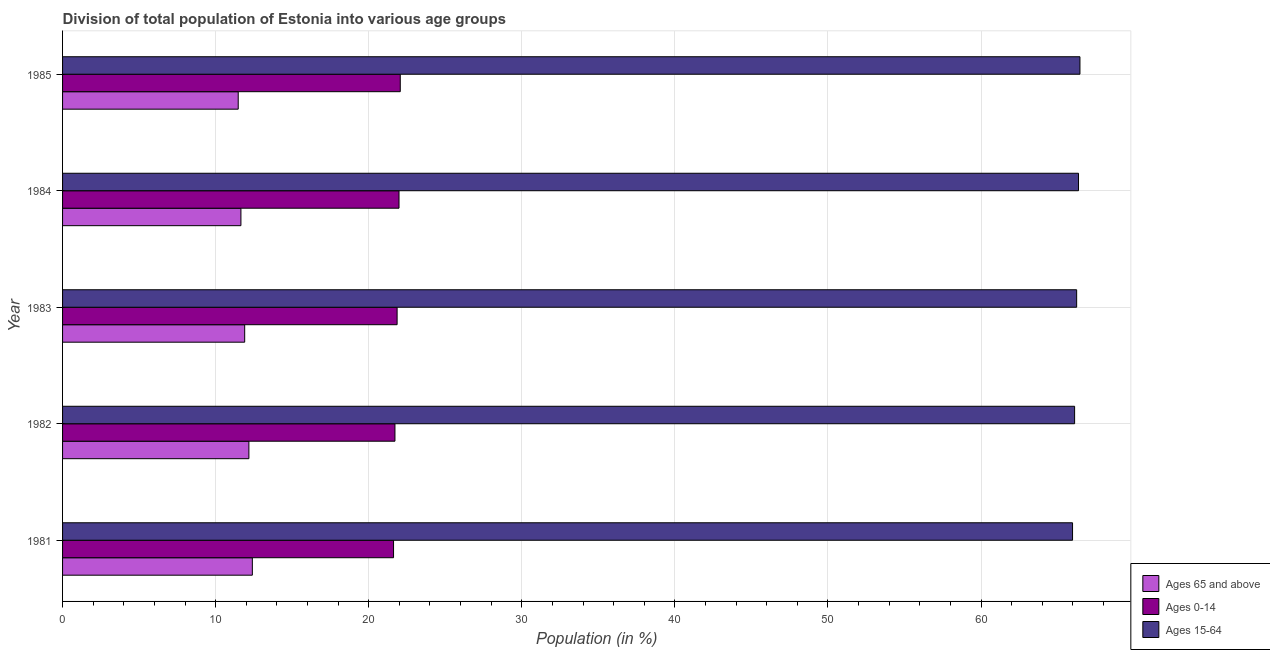How many different coloured bars are there?
Ensure brevity in your answer.  3. How many bars are there on the 4th tick from the top?
Offer a terse response. 3. How many bars are there on the 2nd tick from the bottom?
Your answer should be compact. 3. What is the label of the 3rd group of bars from the top?
Ensure brevity in your answer.  1983. In how many cases, is the number of bars for a given year not equal to the number of legend labels?
Give a very brief answer. 0. What is the percentage of population within the age-group of 65 and above in 1985?
Make the answer very short. 11.48. Across all years, what is the maximum percentage of population within the age-group 0-14?
Provide a short and direct response. 22.06. Across all years, what is the minimum percentage of population within the age-group 15-64?
Give a very brief answer. 65.98. In which year was the percentage of population within the age-group 0-14 maximum?
Keep it short and to the point. 1985. In which year was the percentage of population within the age-group 15-64 minimum?
Make the answer very short. 1981. What is the total percentage of population within the age-group of 65 and above in the graph?
Provide a short and direct response. 59.59. What is the difference between the percentage of population within the age-group 15-64 in 1985 and the percentage of population within the age-group 0-14 in 1981?
Make the answer very short. 44.84. What is the average percentage of population within the age-group 0-14 per year?
Your response must be concise. 21.85. In the year 1982, what is the difference between the percentage of population within the age-group 15-64 and percentage of population within the age-group of 65 and above?
Offer a very short reply. 53.94. What is the ratio of the percentage of population within the age-group 0-14 in 1983 to that in 1985?
Offer a very short reply. 0.99. Is the percentage of population within the age-group 0-14 in 1981 less than that in 1984?
Give a very brief answer. Yes. What is the difference between the highest and the second highest percentage of population within the age-group of 65 and above?
Your answer should be very brief. 0.23. What is the difference between the highest and the lowest percentage of population within the age-group 0-14?
Offer a terse response. 0.44. In how many years, is the percentage of population within the age-group of 65 and above greater than the average percentage of population within the age-group of 65 and above taken over all years?
Ensure brevity in your answer.  2. What does the 1st bar from the top in 1984 represents?
Offer a very short reply. Ages 15-64. What does the 2nd bar from the bottom in 1985 represents?
Offer a very short reply. Ages 0-14. What is the difference between two consecutive major ticks on the X-axis?
Offer a very short reply. 10. Are the values on the major ticks of X-axis written in scientific E-notation?
Keep it short and to the point. No. Where does the legend appear in the graph?
Keep it short and to the point. Bottom right. How many legend labels are there?
Your answer should be very brief. 3. What is the title of the graph?
Ensure brevity in your answer.  Division of total population of Estonia into various age groups
. Does "Industrial Nitrous Oxide" appear as one of the legend labels in the graph?
Your answer should be very brief. No. What is the Population (in %) in Ages 65 and above in 1981?
Your answer should be very brief. 12.4. What is the Population (in %) of Ages 0-14 in 1981?
Offer a terse response. 21.62. What is the Population (in %) in Ages 15-64 in 1981?
Your answer should be very brief. 65.98. What is the Population (in %) of Ages 65 and above in 1982?
Offer a very short reply. 12.17. What is the Population (in %) of Ages 0-14 in 1982?
Your answer should be compact. 21.71. What is the Population (in %) in Ages 15-64 in 1982?
Your response must be concise. 66.11. What is the Population (in %) of Ages 65 and above in 1983?
Offer a very short reply. 11.9. What is the Population (in %) in Ages 0-14 in 1983?
Make the answer very short. 21.85. What is the Population (in %) in Ages 15-64 in 1983?
Keep it short and to the point. 66.25. What is the Population (in %) in Ages 65 and above in 1984?
Your response must be concise. 11.65. What is the Population (in %) of Ages 0-14 in 1984?
Keep it short and to the point. 21.98. What is the Population (in %) of Ages 15-64 in 1984?
Give a very brief answer. 66.37. What is the Population (in %) of Ages 65 and above in 1985?
Make the answer very short. 11.48. What is the Population (in %) in Ages 0-14 in 1985?
Your answer should be very brief. 22.06. What is the Population (in %) in Ages 15-64 in 1985?
Ensure brevity in your answer.  66.46. Across all years, what is the maximum Population (in %) in Ages 65 and above?
Your answer should be very brief. 12.4. Across all years, what is the maximum Population (in %) in Ages 0-14?
Offer a very short reply. 22.06. Across all years, what is the maximum Population (in %) in Ages 15-64?
Provide a short and direct response. 66.46. Across all years, what is the minimum Population (in %) in Ages 65 and above?
Make the answer very short. 11.48. Across all years, what is the minimum Population (in %) in Ages 0-14?
Give a very brief answer. 21.62. Across all years, what is the minimum Population (in %) of Ages 15-64?
Keep it short and to the point. 65.98. What is the total Population (in %) of Ages 65 and above in the graph?
Your answer should be very brief. 59.59. What is the total Population (in %) in Ages 0-14 in the graph?
Your response must be concise. 109.23. What is the total Population (in %) of Ages 15-64 in the graph?
Make the answer very short. 331.17. What is the difference between the Population (in %) of Ages 65 and above in 1981 and that in 1982?
Provide a succinct answer. 0.23. What is the difference between the Population (in %) of Ages 0-14 in 1981 and that in 1982?
Your response must be concise. -0.09. What is the difference between the Population (in %) in Ages 15-64 in 1981 and that in 1982?
Offer a very short reply. -0.13. What is the difference between the Population (in %) in Ages 65 and above in 1981 and that in 1983?
Provide a short and direct response. 0.5. What is the difference between the Population (in %) in Ages 0-14 in 1981 and that in 1983?
Your answer should be very brief. -0.23. What is the difference between the Population (in %) of Ages 15-64 in 1981 and that in 1983?
Keep it short and to the point. -0.27. What is the difference between the Population (in %) in Ages 65 and above in 1981 and that in 1984?
Make the answer very short. 0.75. What is the difference between the Population (in %) of Ages 0-14 in 1981 and that in 1984?
Ensure brevity in your answer.  -0.36. What is the difference between the Population (in %) of Ages 15-64 in 1981 and that in 1984?
Offer a very short reply. -0.39. What is the difference between the Population (in %) of Ages 65 and above in 1981 and that in 1985?
Offer a terse response. 0.92. What is the difference between the Population (in %) of Ages 0-14 in 1981 and that in 1985?
Offer a very short reply. -0.44. What is the difference between the Population (in %) in Ages 15-64 in 1981 and that in 1985?
Provide a succinct answer. -0.48. What is the difference between the Population (in %) in Ages 65 and above in 1982 and that in 1983?
Make the answer very short. 0.27. What is the difference between the Population (in %) in Ages 0-14 in 1982 and that in 1983?
Provide a short and direct response. -0.14. What is the difference between the Population (in %) of Ages 15-64 in 1982 and that in 1983?
Keep it short and to the point. -0.13. What is the difference between the Population (in %) of Ages 65 and above in 1982 and that in 1984?
Provide a short and direct response. 0.52. What is the difference between the Population (in %) in Ages 0-14 in 1982 and that in 1984?
Make the answer very short. -0.27. What is the difference between the Population (in %) in Ages 15-64 in 1982 and that in 1984?
Your answer should be compact. -0.26. What is the difference between the Population (in %) of Ages 65 and above in 1982 and that in 1985?
Offer a very short reply. 0.7. What is the difference between the Population (in %) of Ages 0-14 in 1982 and that in 1985?
Make the answer very short. -0.35. What is the difference between the Population (in %) in Ages 15-64 in 1982 and that in 1985?
Offer a very short reply. -0.35. What is the difference between the Population (in %) of Ages 65 and above in 1983 and that in 1984?
Your response must be concise. 0.25. What is the difference between the Population (in %) in Ages 0-14 in 1983 and that in 1984?
Your answer should be compact. -0.12. What is the difference between the Population (in %) in Ages 15-64 in 1983 and that in 1984?
Offer a very short reply. -0.12. What is the difference between the Population (in %) of Ages 65 and above in 1983 and that in 1985?
Offer a very short reply. 0.42. What is the difference between the Population (in %) of Ages 0-14 in 1983 and that in 1985?
Your response must be concise. -0.21. What is the difference between the Population (in %) in Ages 15-64 in 1983 and that in 1985?
Your answer should be very brief. -0.22. What is the difference between the Population (in %) in Ages 65 and above in 1984 and that in 1985?
Offer a very short reply. 0.18. What is the difference between the Population (in %) in Ages 0-14 in 1984 and that in 1985?
Your answer should be very brief. -0.08. What is the difference between the Population (in %) of Ages 15-64 in 1984 and that in 1985?
Your answer should be compact. -0.09. What is the difference between the Population (in %) in Ages 65 and above in 1981 and the Population (in %) in Ages 0-14 in 1982?
Offer a terse response. -9.32. What is the difference between the Population (in %) in Ages 65 and above in 1981 and the Population (in %) in Ages 15-64 in 1982?
Provide a short and direct response. -53.72. What is the difference between the Population (in %) of Ages 0-14 in 1981 and the Population (in %) of Ages 15-64 in 1982?
Provide a short and direct response. -44.49. What is the difference between the Population (in %) in Ages 65 and above in 1981 and the Population (in %) in Ages 0-14 in 1983?
Provide a short and direct response. -9.46. What is the difference between the Population (in %) in Ages 65 and above in 1981 and the Population (in %) in Ages 15-64 in 1983?
Keep it short and to the point. -53.85. What is the difference between the Population (in %) in Ages 0-14 in 1981 and the Population (in %) in Ages 15-64 in 1983?
Offer a terse response. -44.63. What is the difference between the Population (in %) of Ages 65 and above in 1981 and the Population (in %) of Ages 0-14 in 1984?
Provide a succinct answer. -9.58. What is the difference between the Population (in %) in Ages 65 and above in 1981 and the Population (in %) in Ages 15-64 in 1984?
Your answer should be very brief. -53.97. What is the difference between the Population (in %) in Ages 0-14 in 1981 and the Population (in %) in Ages 15-64 in 1984?
Your response must be concise. -44.75. What is the difference between the Population (in %) in Ages 65 and above in 1981 and the Population (in %) in Ages 0-14 in 1985?
Your answer should be compact. -9.66. What is the difference between the Population (in %) of Ages 65 and above in 1981 and the Population (in %) of Ages 15-64 in 1985?
Keep it short and to the point. -54.07. What is the difference between the Population (in %) in Ages 0-14 in 1981 and the Population (in %) in Ages 15-64 in 1985?
Your answer should be very brief. -44.84. What is the difference between the Population (in %) of Ages 65 and above in 1982 and the Population (in %) of Ages 0-14 in 1983?
Offer a very short reply. -9.68. What is the difference between the Population (in %) of Ages 65 and above in 1982 and the Population (in %) of Ages 15-64 in 1983?
Provide a short and direct response. -54.08. What is the difference between the Population (in %) in Ages 0-14 in 1982 and the Population (in %) in Ages 15-64 in 1983?
Provide a short and direct response. -44.53. What is the difference between the Population (in %) of Ages 65 and above in 1982 and the Population (in %) of Ages 0-14 in 1984?
Your answer should be compact. -9.81. What is the difference between the Population (in %) of Ages 65 and above in 1982 and the Population (in %) of Ages 15-64 in 1984?
Offer a terse response. -54.2. What is the difference between the Population (in %) in Ages 0-14 in 1982 and the Population (in %) in Ages 15-64 in 1984?
Your response must be concise. -44.66. What is the difference between the Population (in %) in Ages 65 and above in 1982 and the Population (in %) in Ages 0-14 in 1985?
Your answer should be very brief. -9.89. What is the difference between the Population (in %) of Ages 65 and above in 1982 and the Population (in %) of Ages 15-64 in 1985?
Give a very brief answer. -54.29. What is the difference between the Population (in %) in Ages 0-14 in 1982 and the Population (in %) in Ages 15-64 in 1985?
Make the answer very short. -44.75. What is the difference between the Population (in %) of Ages 65 and above in 1983 and the Population (in %) of Ages 0-14 in 1984?
Your response must be concise. -10.08. What is the difference between the Population (in %) in Ages 65 and above in 1983 and the Population (in %) in Ages 15-64 in 1984?
Your answer should be very brief. -54.47. What is the difference between the Population (in %) in Ages 0-14 in 1983 and the Population (in %) in Ages 15-64 in 1984?
Offer a very short reply. -44.51. What is the difference between the Population (in %) in Ages 65 and above in 1983 and the Population (in %) in Ages 0-14 in 1985?
Offer a terse response. -10.16. What is the difference between the Population (in %) in Ages 65 and above in 1983 and the Population (in %) in Ages 15-64 in 1985?
Provide a short and direct response. -54.57. What is the difference between the Population (in %) of Ages 0-14 in 1983 and the Population (in %) of Ages 15-64 in 1985?
Your answer should be compact. -44.61. What is the difference between the Population (in %) of Ages 65 and above in 1984 and the Population (in %) of Ages 0-14 in 1985?
Offer a terse response. -10.41. What is the difference between the Population (in %) of Ages 65 and above in 1984 and the Population (in %) of Ages 15-64 in 1985?
Your answer should be very brief. -54.81. What is the difference between the Population (in %) in Ages 0-14 in 1984 and the Population (in %) in Ages 15-64 in 1985?
Your response must be concise. -44.48. What is the average Population (in %) in Ages 65 and above per year?
Your answer should be very brief. 11.92. What is the average Population (in %) of Ages 0-14 per year?
Offer a terse response. 21.85. What is the average Population (in %) in Ages 15-64 per year?
Provide a short and direct response. 66.23. In the year 1981, what is the difference between the Population (in %) in Ages 65 and above and Population (in %) in Ages 0-14?
Ensure brevity in your answer.  -9.22. In the year 1981, what is the difference between the Population (in %) in Ages 65 and above and Population (in %) in Ages 15-64?
Provide a succinct answer. -53.58. In the year 1981, what is the difference between the Population (in %) of Ages 0-14 and Population (in %) of Ages 15-64?
Provide a succinct answer. -44.36. In the year 1982, what is the difference between the Population (in %) in Ages 65 and above and Population (in %) in Ages 0-14?
Provide a short and direct response. -9.54. In the year 1982, what is the difference between the Population (in %) of Ages 65 and above and Population (in %) of Ages 15-64?
Ensure brevity in your answer.  -53.94. In the year 1982, what is the difference between the Population (in %) in Ages 0-14 and Population (in %) in Ages 15-64?
Provide a short and direct response. -44.4. In the year 1983, what is the difference between the Population (in %) in Ages 65 and above and Population (in %) in Ages 0-14?
Ensure brevity in your answer.  -9.96. In the year 1983, what is the difference between the Population (in %) of Ages 65 and above and Population (in %) of Ages 15-64?
Keep it short and to the point. -54.35. In the year 1983, what is the difference between the Population (in %) of Ages 0-14 and Population (in %) of Ages 15-64?
Offer a terse response. -44.39. In the year 1984, what is the difference between the Population (in %) in Ages 65 and above and Population (in %) in Ages 0-14?
Offer a very short reply. -10.33. In the year 1984, what is the difference between the Population (in %) of Ages 65 and above and Population (in %) of Ages 15-64?
Your answer should be compact. -54.72. In the year 1984, what is the difference between the Population (in %) in Ages 0-14 and Population (in %) in Ages 15-64?
Offer a very short reply. -44.39. In the year 1985, what is the difference between the Population (in %) of Ages 65 and above and Population (in %) of Ages 0-14?
Keep it short and to the point. -10.59. In the year 1985, what is the difference between the Population (in %) of Ages 65 and above and Population (in %) of Ages 15-64?
Offer a terse response. -54.99. In the year 1985, what is the difference between the Population (in %) in Ages 0-14 and Population (in %) in Ages 15-64?
Give a very brief answer. -44.4. What is the ratio of the Population (in %) of Ages 65 and above in 1981 to that in 1982?
Provide a succinct answer. 1.02. What is the ratio of the Population (in %) in Ages 0-14 in 1981 to that in 1982?
Offer a terse response. 1. What is the ratio of the Population (in %) in Ages 15-64 in 1981 to that in 1982?
Ensure brevity in your answer.  1. What is the ratio of the Population (in %) of Ages 65 and above in 1981 to that in 1983?
Provide a short and direct response. 1.04. What is the ratio of the Population (in %) of Ages 0-14 in 1981 to that in 1983?
Make the answer very short. 0.99. What is the ratio of the Population (in %) of Ages 15-64 in 1981 to that in 1983?
Provide a short and direct response. 1. What is the ratio of the Population (in %) in Ages 65 and above in 1981 to that in 1984?
Offer a very short reply. 1.06. What is the ratio of the Population (in %) in Ages 0-14 in 1981 to that in 1984?
Offer a very short reply. 0.98. What is the ratio of the Population (in %) in Ages 65 and above in 1981 to that in 1985?
Provide a short and direct response. 1.08. What is the ratio of the Population (in %) of Ages 0-14 in 1981 to that in 1985?
Keep it short and to the point. 0.98. What is the ratio of the Population (in %) of Ages 15-64 in 1981 to that in 1985?
Provide a succinct answer. 0.99. What is the ratio of the Population (in %) of Ages 65 and above in 1982 to that in 1983?
Your response must be concise. 1.02. What is the ratio of the Population (in %) of Ages 0-14 in 1982 to that in 1983?
Provide a succinct answer. 0.99. What is the ratio of the Population (in %) of Ages 65 and above in 1982 to that in 1984?
Provide a short and direct response. 1.04. What is the ratio of the Population (in %) in Ages 0-14 in 1982 to that in 1984?
Make the answer very short. 0.99. What is the ratio of the Population (in %) in Ages 65 and above in 1982 to that in 1985?
Provide a short and direct response. 1.06. What is the ratio of the Population (in %) of Ages 0-14 in 1982 to that in 1985?
Your response must be concise. 0.98. What is the ratio of the Population (in %) of Ages 15-64 in 1982 to that in 1985?
Offer a terse response. 0.99. What is the ratio of the Population (in %) of Ages 65 and above in 1983 to that in 1984?
Keep it short and to the point. 1.02. What is the ratio of the Population (in %) of Ages 15-64 in 1983 to that in 1984?
Offer a terse response. 1. What is the ratio of the Population (in %) in Ages 65 and above in 1983 to that in 1985?
Provide a succinct answer. 1.04. What is the ratio of the Population (in %) of Ages 0-14 in 1983 to that in 1985?
Provide a short and direct response. 0.99. What is the ratio of the Population (in %) of Ages 65 and above in 1984 to that in 1985?
Keep it short and to the point. 1.02. What is the ratio of the Population (in %) in Ages 0-14 in 1984 to that in 1985?
Ensure brevity in your answer.  1. What is the ratio of the Population (in %) in Ages 15-64 in 1984 to that in 1985?
Your response must be concise. 1. What is the difference between the highest and the second highest Population (in %) in Ages 65 and above?
Offer a very short reply. 0.23. What is the difference between the highest and the second highest Population (in %) of Ages 0-14?
Your response must be concise. 0.08. What is the difference between the highest and the second highest Population (in %) of Ages 15-64?
Offer a very short reply. 0.09. What is the difference between the highest and the lowest Population (in %) in Ages 65 and above?
Your answer should be compact. 0.92. What is the difference between the highest and the lowest Population (in %) of Ages 0-14?
Your answer should be very brief. 0.44. What is the difference between the highest and the lowest Population (in %) of Ages 15-64?
Keep it short and to the point. 0.48. 